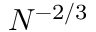<formula> <loc_0><loc_0><loc_500><loc_500>N ^ { - 2 / 3 }</formula> 